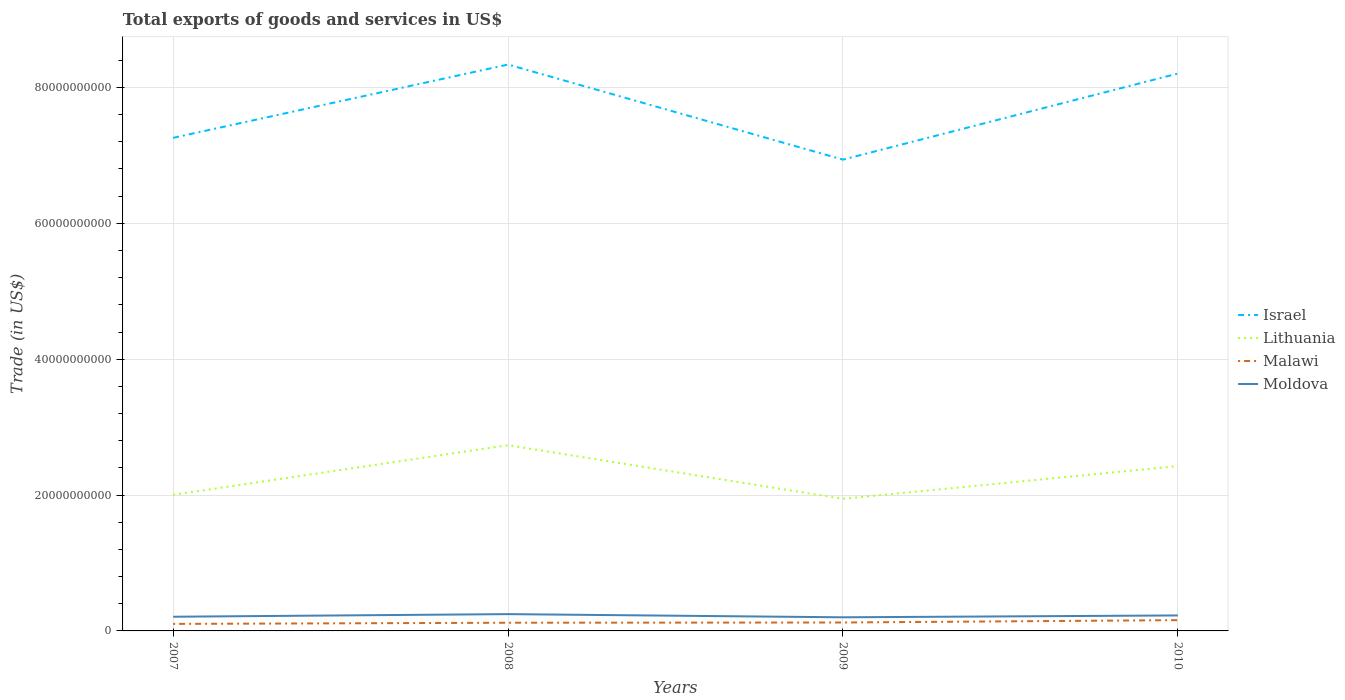Does the line corresponding to Israel intersect with the line corresponding to Moldova?
Keep it short and to the point. No. Is the number of lines equal to the number of legend labels?
Offer a terse response. Yes. Across all years, what is the maximum total exports of goods and services in Malawi?
Give a very brief answer. 1.03e+09. What is the total total exports of goods and services in Malawi in the graph?
Your response must be concise. -3.46e+08. What is the difference between the highest and the second highest total exports of goods and services in Malawi?
Provide a succinct answer. 5.53e+08. What is the difference between the highest and the lowest total exports of goods and services in Lithuania?
Your answer should be very brief. 2. Is the total exports of goods and services in Israel strictly greater than the total exports of goods and services in Malawi over the years?
Ensure brevity in your answer.  No. What is the difference between two consecutive major ticks on the Y-axis?
Make the answer very short. 2.00e+1. Does the graph contain any zero values?
Make the answer very short. No. Where does the legend appear in the graph?
Keep it short and to the point. Center right. How are the legend labels stacked?
Your answer should be compact. Vertical. What is the title of the graph?
Your answer should be compact. Total exports of goods and services in US$. Does "Venezuela" appear as one of the legend labels in the graph?
Offer a terse response. No. What is the label or title of the Y-axis?
Offer a terse response. Trade (in US$). What is the Trade (in US$) in Israel in 2007?
Your answer should be very brief. 7.26e+1. What is the Trade (in US$) of Lithuania in 2007?
Offer a very short reply. 2.00e+1. What is the Trade (in US$) of Malawi in 2007?
Your answer should be very brief. 1.03e+09. What is the Trade (in US$) of Moldova in 2007?
Offer a very short reply. 2.09e+09. What is the Trade (in US$) of Israel in 2008?
Offer a terse response. 8.34e+1. What is the Trade (in US$) in Lithuania in 2008?
Give a very brief answer. 2.73e+1. What is the Trade (in US$) of Malawi in 2008?
Offer a terse response. 1.21e+09. What is the Trade (in US$) of Moldova in 2008?
Provide a short and direct response. 2.47e+09. What is the Trade (in US$) in Israel in 2009?
Make the answer very short. 6.94e+1. What is the Trade (in US$) in Lithuania in 2009?
Make the answer very short. 1.94e+1. What is the Trade (in US$) in Malawi in 2009?
Offer a terse response. 1.24e+09. What is the Trade (in US$) of Moldova in 2009?
Give a very brief answer. 2.01e+09. What is the Trade (in US$) in Israel in 2010?
Provide a short and direct response. 8.20e+1. What is the Trade (in US$) in Lithuania in 2010?
Provide a short and direct response. 2.43e+1. What is the Trade (in US$) in Malawi in 2010?
Offer a very short reply. 1.59e+09. What is the Trade (in US$) of Moldova in 2010?
Your answer should be very brief. 2.28e+09. Across all years, what is the maximum Trade (in US$) of Israel?
Offer a very short reply. 8.34e+1. Across all years, what is the maximum Trade (in US$) in Lithuania?
Provide a short and direct response. 2.73e+1. Across all years, what is the maximum Trade (in US$) in Malawi?
Offer a terse response. 1.59e+09. Across all years, what is the maximum Trade (in US$) of Moldova?
Your answer should be very brief. 2.47e+09. Across all years, what is the minimum Trade (in US$) in Israel?
Your answer should be compact. 6.94e+1. Across all years, what is the minimum Trade (in US$) of Lithuania?
Your answer should be very brief. 1.94e+1. Across all years, what is the minimum Trade (in US$) of Malawi?
Give a very brief answer. 1.03e+09. Across all years, what is the minimum Trade (in US$) of Moldova?
Offer a very short reply. 2.01e+09. What is the total Trade (in US$) in Israel in the graph?
Provide a short and direct response. 3.07e+11. What is the total Trade (in US$) in Lithuania in the graph?
Offer a very short reply. 9.11e+1. What is the total Trade (in US$) of Malawi in the graph?
Your answer should be compact. 5.06e+09. What is the total Trade (in US$) in Moldova in the graph?
Ensure brevity in your answer.  8.85e+09. What is the difference between the Trade (in US$) of Israel in 2007 and that in 2008?
Your response must be concise. -1.08e+1. What is the difference between the Trade (in US$) of Lithuania in 2007 and that in 2008?
Provide a short and direct response. -7.31e+09. What is the difference between the Trade (in US$) in Malawi in 2007 and that in 2008?
Provide a short and direct response. -1.72e+08. What is the difference between the Trade (in US$) of Moldova in 2007 and that in 2008?
Make the answer very short. -3.83e+08. What is the difference between the Trade (in US$) in Israel in 2007 and that in 2009?
Ensure brevity in your answer.  3.21e+09. What is the difference between the Trade (in US$) of Lithuania in 2007 and that in 2009?
Your answer should be very brief. 5.89e+08. What is the difference between the Trade (in US$) of Malawi in 2007 and that in 2009?
Offer a very short reply. -2.07e+08. What is the difference between the Trade (in US$) of Moldova in 2007 and that in 2009?
Keep it short and to the point. 8.28e+07. What is the difference between the Trade (in US$) in Israel in 2007 and that in 2010?
Make the answer very short. -9.47e+09. What is the difference between the Trade (in US$) of Lithuania in 2007 and that in 2010?
Your answer should be compact. -4.23e+09. What is the difference between the Trade (in US$) of Malawi in 2007 and that in 2010?
Offer a very short reply. -5.53e+08. What is the difference between the Trade (in US$) of Moldova in 2007 and that in 2010?
Provide a succinct answer. -1.91e+08. What is the difference between the Trade (in US$) of Israel in 2008 and that in 2009?
Offer a terse response. 1.40e+1. What is the difference between the Trade (in US$) of Lithuania in 2008 and that in 2009?
Make the answer very short. 7.89e+09. What is the difference between the Trade (in US$) in Malawi in 2008 and that in 2009?
Your answer should be very brief. -3.44e+07. What is the difference between the Trade (in US$) of Moldova in 2008 and that in 2009?
Keep it short and to the point. 4.66e+08. What is the difference between the Trade (in US$) in Israel in 2008 and that in 2010?
Provide a succinct answer. 1.32e+09. What is the difference between the Trade (in US$) of Lithuania in 2008 and that in 2010?
Make the answer very short. 3.08e+09. What is the difference between the Trade (in US$) of Malawi in 2008 and that in 2010?
Offer a very short reply. -3.80e+08. What is the difference between the Trade (in US$) of Moldova in 2008 and that in 2010?
Keep it short and to the point. 1.92e+08. What is the difference between the Trade (in US$) in Israel in 2009 and that in 2010?
Make the answer very short. -1.27e+1. What is the difference between the Trade (in US$) of Lithuania in 2009 and that in 2010?
Offer a very short reply. -4.82e+09. What is the difference between the Trade (in US$) in Malawi in 2009 and that in 2010?
Keep it short and to the point. -3.46e+08. What is the difference between the Trade (in US$) of Moldova in 2009 and that in 2010?
Ensure brevity in your answer.  -2.74e+08. What is the difference between the Trade (in US$) of Israel in 2007 and the Trade (in US$) of Lithuania in 2008?
Offer a very short reply. 4.52e+1. What is the difference between the Trade (in US$) of Israel in 2007 and the Trade (in US$) of Malawi in 2008?
Provide a short and direct response. 7.14e+1. What is the difference between the Trade (in US$) in Israel in 2007 and the Trade (in US$) in Moldova in 2008?
Keep it short and to the point. 7.01e+1. What is the difference between the Trade (in US$) in Lithuania in 2007 and the Trade (in US$) in Malawi in 2008?
Your answer should be very brief. 1.88e+1. What is the difference between the Trade (in US$) of Lithuania in 2007 and the Trade (in US$) of Moldova in 2008?
Your answer should be very brief. 1.76e+1. What is the difference between the Trade (in US$) of Malawi in 2007 and the Trade (in US$) of Moldova in 2008?
Provide a succinct answer. -1.44e+09. What is the difference between the Trade (in US$) in Israel in 2007 and the Trade (in US$) in Lithuania in 2009?
Offer a very short reply. 5.31e+1. What is the difference between the Trade (in US$) of Israel in 2007 and the Trade (in US$) of Malawi in 2009?
Your answer should be compact. 7.13e+1. What is the difference between the Trade (in US$) of Israel in 2007 and the Trade (in US$) of Moldova in 2009?
Your answer should be compact. 7.06e+1. What is the difference between the Trade (in US$) in Lithuania in 2007 and the Trade (in US$) in Malawi in 2009?
Your answer should be very brief. 1.88e+1. What is the difference between the Trade (in US$) in Lithuania in 2007 and the Trade (in US$) in Moldova in 2009?
Keep it short and to the point. 1.80e+1. What is the difference between the Trade (in US$) of Malawi in 2007 and the Trade (in US$) of Moldova in 2009?
Your answer should be very brief. -9.72e+08. What is the difference between the Trade (in US$) in Israel in 2007 and the Trade (in US$) in Lithuania in 2010?
Your answer should be compact. 4.83e+1. What is the difference between the Trade (in US$) in Israel in 2007 and the Trade (in US$) in Malawi in 2010?
Offer a very short reply. 7.10e+1. What is the difference between the Trade (in US$) in Israel in 2007 and the Trade (in US$) in Moldova in 2010?
Provide a short and direct response. 7.03e+1. What is the difference between the Trade (in US$) of Lithuania in 2007 and the Trade (in US$) of Malawi in 2010?
Provide a short and direct response. 1.84e+1. What is the difference between the Trade (in US$) in Lithuania in 2007 and the Trade (in US$) in Moldova in 2010?
Offer a very short reply. 1.78e+1. What is the difference between the Trade (in US$) in Malawi in 2007 and the Trade (in US$) in Moldova in 2010?
Provide a short and direct response. -1.25e+09. What is the difference between the Trade (in US$) in Israel in 2008 and the Trade (in US$) in Lithuania in 2009?
Keep it short and to the point. 6.39e+1. What is the difference between the Trade (in US$) of Israel in 2008 and the Trade (in US$) of Malawi in 2009?
Keep it short and to the point. 8.21e+1. What is the difference between the Trade (in US$) of Israel in 2008 and the Trade (in US$) of Moldova in 2009?
Offer a terse response. 8.14e+1. What is the difference between the Trade (in US$) of Lithuania in 2008 and the Trade (in US$) of Malawi in 2009?
Offer a very short reply. 2.61e+1. What is the difference between the Trade (in US$) in Lithuania in 2008 and the Trade (in US$) in Moldova in 2009?
Ensure brevity in your answer.  2.53e+1. What is the difference between the Trade (in US$) of Malawi in 2008 and the Trade (in US$) of Moldova in 2009?
Make the answer very short. -8.00e+08. What is the difference between the Trade (in US$) of Israel in 2008 and the Trade (in US$) of Lithuania in 2010?
Your answer should be compact. 5.91e+1. What is the difference between the Trade (in US$) in Israel in 2008 and the Trade (in US$) in Malawi in 2010?
Offer a terse response. 8.18e+1. What is the difference between the Trade (in US$) of Israel in 2008 and the Trade (in US$) of Moldova in 2010?
Your answer should be very brief. 8.11e+1. What is the difference between the Trade (in US$) in Lithuania in 2008 and the Trade (in US$) in Malawi in 2010?
Your answer should be compact. 2.58e+1. What is the difference between the Trade (in US$) of Lithuania in 2008 and the Trade (in US$) of Moldova in 2010?
Provide a succinct answer. 2.51e+1. What is the difference between the Trade (in US$) in Malawi in 2008 and the Trade (in US$) in Moldova in 2010?
Keep it short and to the point. -1.07e+09. What is the difference between the Trade (in US$) in Israel in 2009 and the Trade (in US$) in Lithuania in 2010?
Offer a terse response. 4.51e+1. What is the difference between the Trade (in US$) of Israel in 2009 and the Trade (in US$) of Malawi in 2010?
Ensure brevity in your answer.  6.78e+1. What is the difference between the Trade (in US$) in Israel in 2009 and the Trade (in US$) in Moldova in 2010?
Provide a short and direct response. 6.71e+1. What is the difference between the Trade (in US$) of Lithuania in 2009 and the Trade (in US$) of Malawi in 2010?
Provide a short and direct response. 1.79e+1. What is the difference between the Trade (in US$) in Lithuania in 2009 and the Trade (in US$) in Moldova in 2010?
Provide a short and direct response. 1.72e+1. What is the difference between the Trade (in US$) in Malawi in 2009 and the Trade (in US$) in Moldova in 2010?
Offer a very short reply. -1.04e+09. What is the average Trade (in US$) in Israel per year?
Ensure brevity in your answer.  7.68e+1. What is the average Trade (in US$) of Lithuania per year?
Keep it short and to the point. 2.28e+1. What is the average Trade (in US$) in Malawi per year?
Provide a short and direct response. 1.27e+09. What is the average Trade (in US$) of Moldova per year?
Your response must be concise. 2.21e+09. In the year 2007, what is the difference between the Trade (in US$) of Israel and Trade (in US$) of Lithuania?
Make the answer very short. 5.25e+1. In the year 2007, what is the difference between the Trade (in US$) in Israel and Trade (in US$) in Malawi?
Offer a very short reply. 7.15e+1. In the year 2007, what is the difference between the Trade (in US$) in Israel and Trade (in US$) in Moldova?
Your response must be concise. 7.05e+1. In the year 2007, what is the difference between the Trade (in US$) of Lithuania and Trade (in US$) of Malawi?
Keep it short and to the point. 1.90e+1. In the year 2007, what is the difference between the Trade (in US$) of Lithuania and Trade (in US$) of Moldova?
Provide a succinct answer. 1.79e+1. In the year 2007, what is the difference between the Trade (in US$) of Malawi and Trade (in US$) of Moldova?
Give a very brief answer. -1.06e+09. In the year 2008, what is the difference between the Trade (in US$) of Israel and Trade (in US$) of Lithuania?
Provide a short and direct response. 5.60e+1. In the year 2008, what is the difference between the Trade (in US$) in Israel and Trade (in US$) in Malawi?
Keep it short and to the point. 8.22e+1. In the year 2008, what is the difference between the Trade (in US$) of Israel and Trade (in US$) of Moldova?
Your answer should be compact. 8.09e+1. In the year 2008, what is the difference between the Trade (in US$) of Lithuania and Trade (in US$) of Malawi?
Provide a short and direct response. 2.61e+1. In the year 2008, what is the difference between the Trade (in US$) of Lithuania and Trade (in US$) of Moldova?
Give a very brief answer. 2.49e+1. In the year 2008, what is the difference between the Trade (in US$) in Malawi and Trade (in US$) in Moldova?
Provide a succinct answer. -1.27e+09. In the year 2009, what is the difference between the Trade (in US$) of Israel and Trade (in US$) of Lithuania?
Your answer should be very brief. 4.99e+1. In the year 2009, what is the difference between the Trade (in US$) in Israel and Trade (in US$) in Malawi?
Your answer should be compact. 6.81e+1. In the year 2009, what is the difference between the Trade (in US$) of Israel and Trade (in US$) of Moldova?
Give a very brief answer. 6.74e+1. In the year 2009, what is the difference between the Trade (in US$) of Lithuania and Trade (in US$) of Malawi?
Offer a very short reply. 1.82e+1. In the year 2009, what is the difference between the Trade (in US$) of Lithuania and Trade (in US$) of Moldova?
Keep it short and to the point. 1.74e+1. In the year 2009, what is the difference between the Trade (in US$) in Malawi and Trade (in US$) in Moldova?
Provide a succinct answer. -7.66e+08. In the year 2010, what is the difference between the Trade (in US$) of Israel and Trade (in US$) of Lithuania?
Your answer should be compact. 5.78e+1. In the year 2010, what is the difference between the Trade (in US$) of Israel and Trade (in US$) of Malawi?
Offer a terse response. 8.05e+1. In the year 2010, what is the difference between the Trade (in US$) of Israel and Trade (in US$) of Moldova?
Offer a very short reply. 7.98e+1. In the year 2010, what is the difference between the Trade (in US$) of Lithuania and Trade (in US$) of Malawi?
Keep it short and to the point. 2.27e+1. In the year 2010, what is the difference between the Trade (in US$) in Lithuania and Trade (in US$) in Moldova?
Give a very brief answer. 2.20e+1. In the year 2010, what is the difference between the Trade (in US$) in Malawi and Trade (in US$) in Moldova?
Offer a very short reply. -6.94e+08. What is the ratio of the Trade (in US$) in Israel in 2007 to that in 2008?
Make the answer very short. 0.87. What is the ratio of the Trade (in US$) in Lithuania in 2007 to that in 2008?
Give a very brief answer. 0.73. What is the ratio of the Trade (in US$) in Malawi in 2007 to that in 2008?
Offer a very short reply. 0.86. What is the ratio of the Trade (in US$) in Moldova in 2007 to that in 2008?
Provide a succinct answer. 0.84. What is the ratio of the Trade (in US$) of Israel in 2007 to that in 2009?
Make the answer very short. 1.05. What is the ratio of the Trade (in US$) in Lithuania in 2007 to that in 2009?
Your response must be concise. 1.03. What is the ratio of the Trade (in US$) of Malawi in 2007 to that in 2009?
Provide a short and direct response. 0.83. What is the ratio of the Trade (in US$) in Moldova in 2007 to that in 2009?
Give a very brief answer. 1.04. What is the ratio of the Trade (in US$) in Israel in 2007 to that in 2010?
Give a very brief answer. 0.88. What is the ratio of the Trade (in US$) of Lithuania in 2007 to that in 2010?
Offer a terse response. 0.83. What is the ratio of the Trade (in US$) of Malawi in 2007 to that in 2010?
Offer a very short reply. 0.65. What is the ratio of the Trade (in US$) in Moldova in 2007 to that in 2010?
Ensure brevity in your answer.  0.92. What is the ratio of the Trade (in US$) of Israel in 2008 to that in 2009?
Make the answer very short. 1.2. What is the ratio of the Trade (in US$) in Lithuania in 2008 to that in 2009?
Ensure brevity in your answer.  1.41. What is the ratio of the Trade (in US$) in Malawi in 2008 to that in 2009?
Provide a succinct answer. 0.97. What is the ratio of the Trade (in US$) of Moldova in 2008 to that in 2009?
Your answer should be very brief. 1.23. What is the ratio of the Trade (in US$) in Israel in 2008 to that in 2010?
Keep it short and to the point. 1.02. What is the ratio of the Trade (in US$) of Lithuania in 2008 to that in 2010?
Ensure brevity in your answer.  1.13. What is the ratio of the Trade (in US$) of Malawi in 2008 to that in 2010?
Make the answer very short. 0.76. What is the ratio of the Trade (in US$) of Moldova in 2008 to that in 2010?
Your answer should be very brief. 1.08. What is the ratio of the Trade (in US$) in Israel in 2009 to that in 2010?
Your response must be concise. 0.85. What is the ratio of the Trade (in US$) in Lithuania in 2009 to that in 2010?
Keep it short and to the point. 0.8. What is the ratio of the Trade (in US$) of Malawi in 2009 to that in 2010?
Ensure brevity in your answer.  0.78. What is the ratio of the Trade (in US$) in Moldova in 2009 to that in 2010?
Your answer should be very brief. 0.88. What is the difference between the highest and the second highest Trade (in US$) in Israel?
Give a very brief answer. 1.32e+09. What is the difference between the highest and the second highest Trade (in US$) of Lithuania?
Keep it short and to the point. 3.08e+09. What is the difference between the highest and the second highest Trade (in US$) of Malawi?
Provide a short and direct response. 3.46e+08. What is the difference between the highest and the second highest Trade (in US$) in Moldova?
Offer a very short reply. 1.92e+08. What is the difference between the highest and the lowest Trade (in US$) of Israel?
Make the answer very short. 1.40e+1. What is the difference between the highest and the lowest Trade (in US$) in Lithuania?
Your answer should be compact. 7.89e+09. What is the difference between the highest and the lowest Trade (in US$) of Malawi?
Ensure brevity in your answer.  5.53e+08. What is the difference between the highest and the lowest Trade (in US$) in Moldova?
Keep it short and to the point. 4.66e+08. 